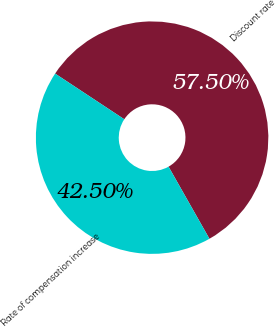Convert chart. <chart><loc_0><loc_0><loc_500><loc_500><pie_chart><fcel>Discount rate<fcel>Rate of compensation increase<nl><fcel>57.5%<fcel>42.5%<nl></chart> 